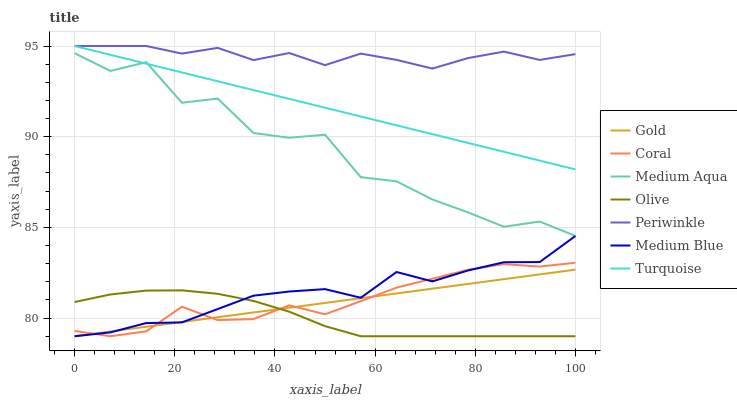Does Olive have the minimum area under the curve?
Answer yes or no. Yes. Does Periwinkle have the maximum area under the curve?
Answer yes or no. Yes. Does Gold have the minimum area under the curve?
Answer yes or no. No. Does Gold have the maximum area under the curve?
Answer yes or no. No. Is Gold the smoothest?
Answer yes or no. Yes. Is Medium Aqua the roughest?
Answer yes or no. Yes. Is Coral the smoothest?
Answer yes or no. No. Is Coral the roughest?
Answer yes or no. No. Does Gold have the lowest value?
Answer yes or no. Yes. Does Periwinkle have the lowest value?
Answer yes or no. No. Does Periwinkle have the highest value?
Answer yes or no. Yes. Does Gold have the highest value?
Answer yes or no. No. Is Gold less than Periwinkle?
Answer yes or no. Yes. Is Turquoise greater than Olive?
Answer yes or no. Yes. Does Gold intersect Olive?
Answer yes or no. Yes. Is Gold less than Olive?
Answer yes or no. No. Is Gold greater than Olive?
Answer yes or no. No. Does Gold intersect Periwinkle?
Answer yes or no. No. 